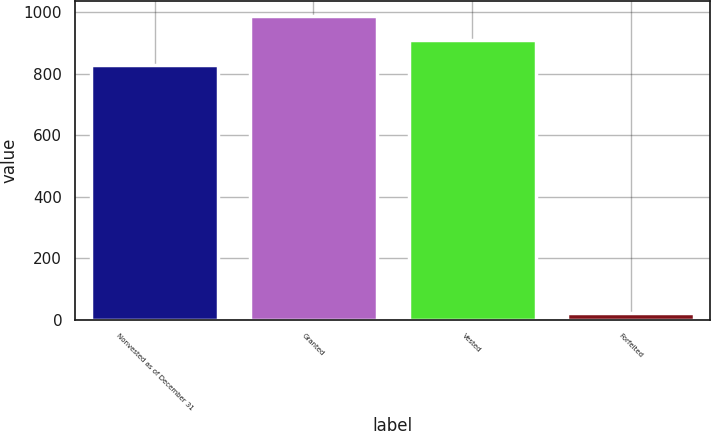<chart> <loc_0><loc_0><loc_500><loc_500><bar_chart><fcel>Nonvested as of December 31<fcel>Granted<fcel>Vested<fcel>Forfeited<nl><fcel>829.7<fcel>987.1<fcel>908.4<fcel>22<nl></chart> 